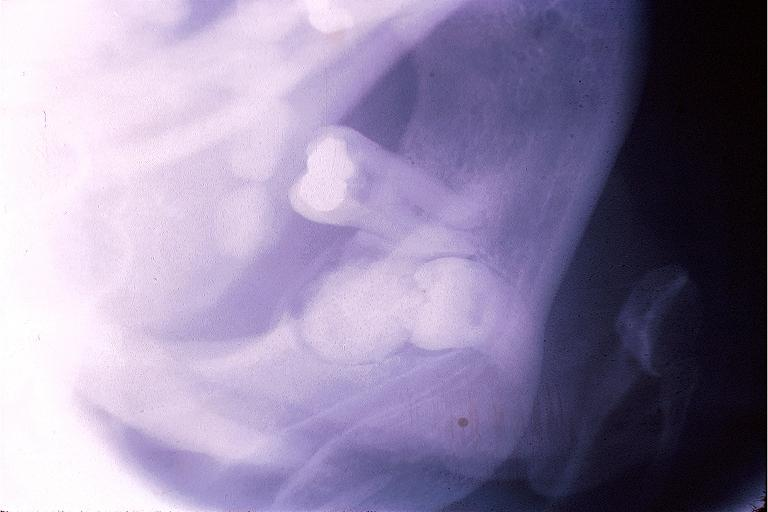s oral present?
Answer the question using a single word or phrase. Yes 